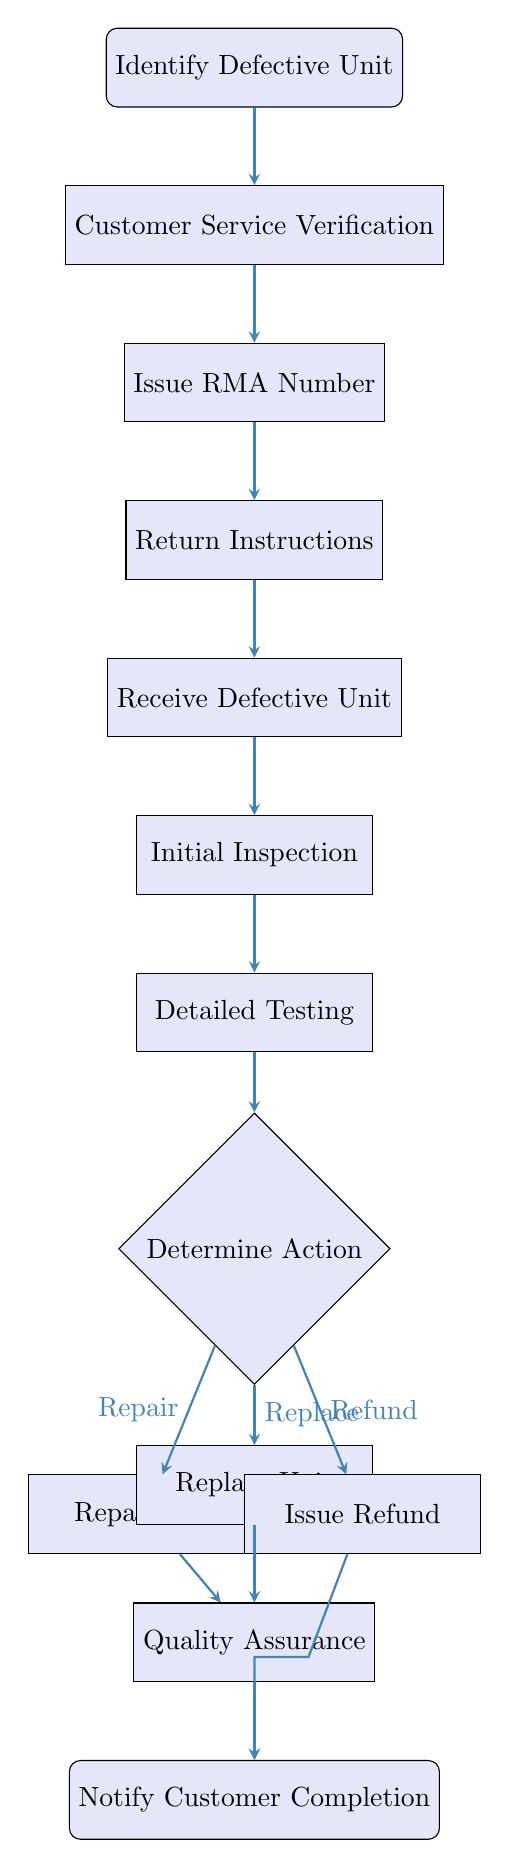What is the first step in the RMA procedure? The flowchart starts with the "Identify Defective Unit" node, which indicates that the process begins when a customer reports an issue with a radio unit.
Answer: Identify Defective Unit How many main processes are there in the diagram? The diagram contains several process nodes: "Identify Defective Unit," "Customer Service Verification," "Issue RMA Number," "Return Instructions," "Receive Defective Unit," "Initial Inspection," "Detailed Testing," "Quality Assurance," and three outcome actions. This totals ten main process nodes.
Answer: Ten What follows after the Customer Service Verification step? According to the flowchart, after "Customer Service Verification," the next step is "Issue RMA Number." This shows the direct flow from customer service verification to issuing an RMA number.
Answer: Issue RMA Number What actions can be taken after the Detailed Testing step? Following "Detailed Testing," the node "Determine Action" indicates that there are three possible actions based on the results: "Repair Unit," "Replace Unit," or "Issue Refund." This requires selecting one of these options based on the test results.
Answer: Repair Unit, Replace Unit, Issue Refund What does the Notify Customer Completion step signify? The "Notify Customer Completion" node signifies the end of the RMA process, where the customer is informed that their request has been completed and they are provided with any necessary tracking information.
Answer: Notify Customer Completion After issuing a refund, what is the next step? The flowchart shows that after "Issue Refund," the process leads directly to "Notify Customer Completion," indicating that the refund decision concludes with customer notification.
Answer: Notify Customer Completion How does the process diverge after determining the action? After the "Determine Action" node, the flow diverges into three paths based on the decision made: "Repair Unit," "Replace Unit," or "Issue Refund," which each leads to different downstream actions.
Answer: Three paths What is the endpoint of the return process? The endpoint of the return process is the "Notify Customer Completion" node, which marks the completion of the RMA procedure regardless of the specific action taken (repair, replace, or refund).
Answer: Notify Customer Completion 